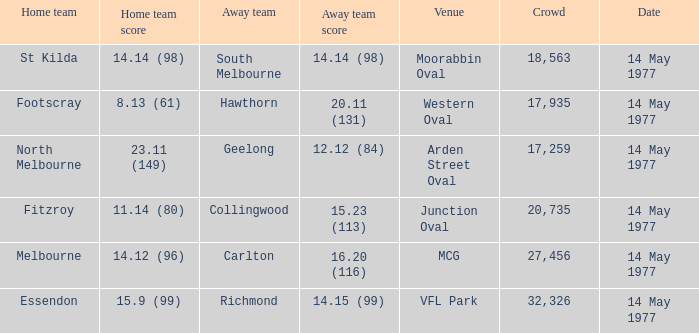How many people were in the crowd with the away team being collingwood? 1.0. 